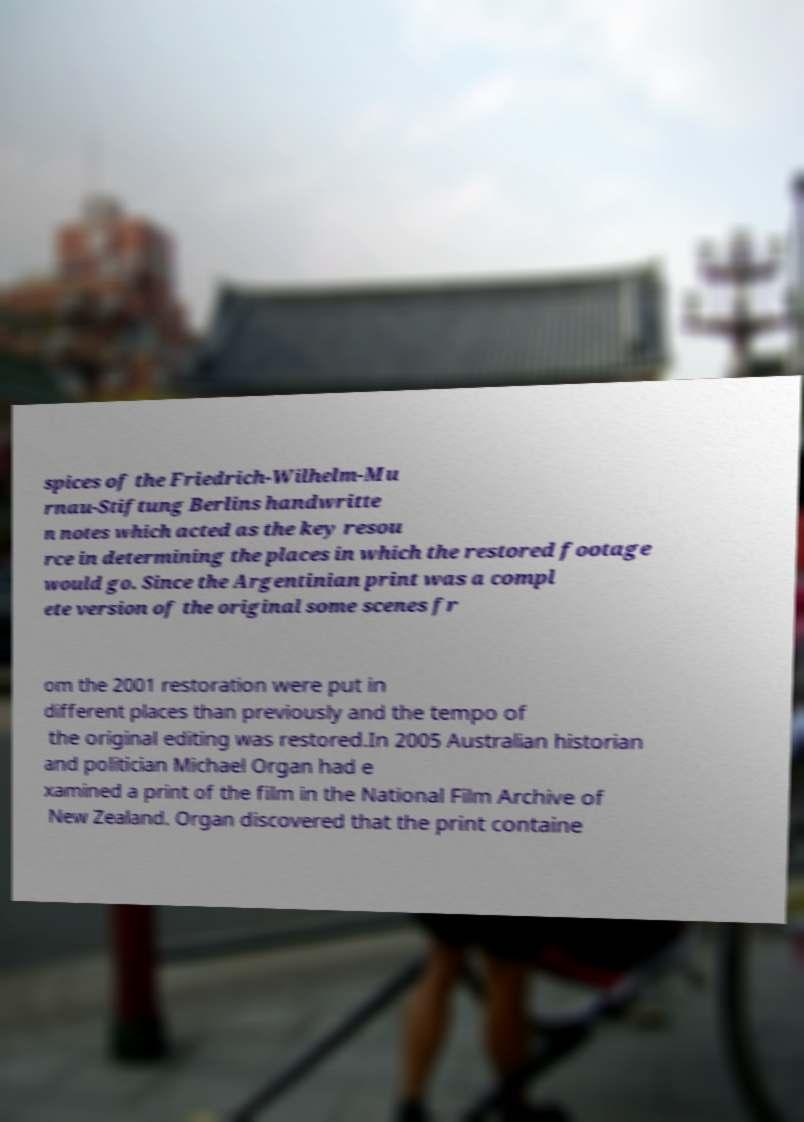Can you accurately transcribe the text from the provided image for me? spices of the Friedrich-Wilhelm-Mu rnau-Stiftung Berlins handwritte n notes which acted as the key resou rce in determining the places in which the restored footage would go. Since the Argentinian print was a compl ete version of the original some scenes fr om the 2001 restoration were put in different places than previously and the tempo of the original editing was restored.In 2005 Australian historian and politician Michael Organ had e xamined a print of the film in the National Film Archive of New Zealand. Organ discovered that the print containe 